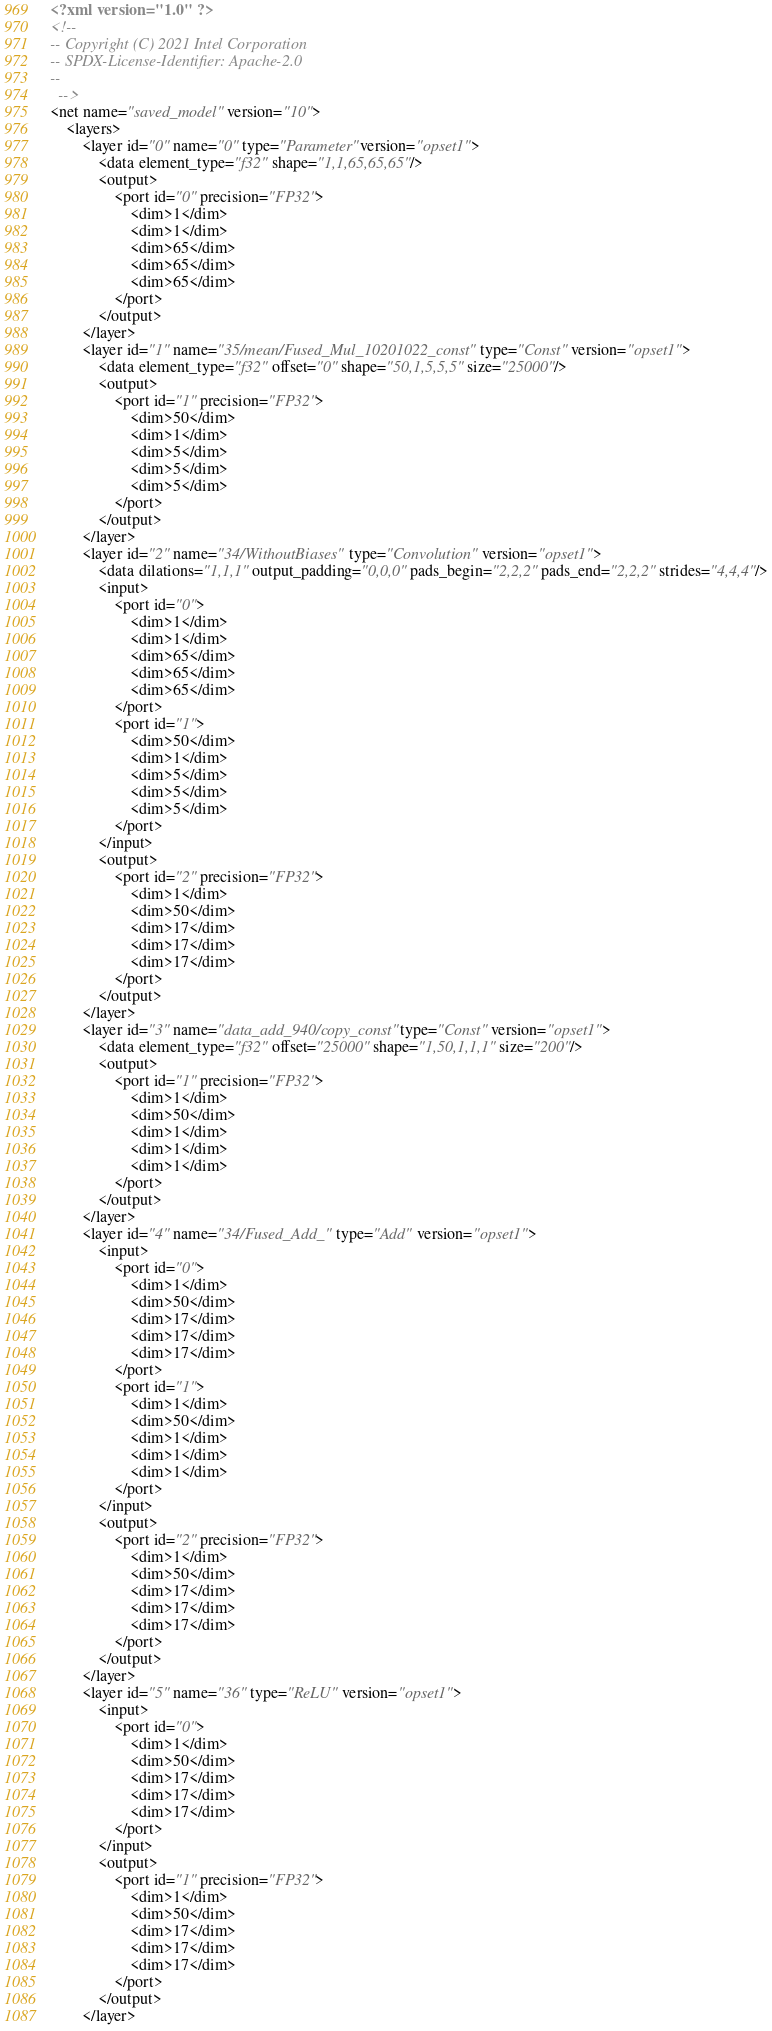<code> <loc_0><loc_0><loc_500><loc_500><_XML_><?xml version="1.0" ?>
<!--
-- Copyright (C) 2021 Intel Corporation
-- SPDX-License-Identifier: Apache-2.0
--
  -->
<net name="saved_model" version="10">
	<layers>
		<layer id="0" name="0" type="Parameter" version="opset1">
			<data element_type="f32" shape="1,1,65,65,65"/>
			<output>
				<port id="0" precision="FP32">
					<dim>1</dim>
					<dim>1</dim>
					<dim>65</dim>
					<dim>65</dim>
					<dim>65</dim>
				</port>
			</output>
		</layer>
		<layer id="1" name="35/mean/Fused_Mul_10201022_const" type="Const" version="opset1">
			<data element_type="f32" offset="0" shape="50,1,5,5,5" size="25000"/>
			<output>
				<port id="1" precision="FP32">
					<dim>50</dim>
					<dim>1</dim>
					<dim>5</dim>
					<dim>5</dim>
					<dim>5</dim>
				</port>
			</output>
		</layer>
		<layer id="2" name="34/WithoutBiases" type="Convolution" version="opset1">
			<data dilations="1,1,1" output_padding="0,0,0" pads_begin="2,2,2" pads_end="2,2,2" strides="4,4,4"/>
			<input>
				<port id="0">
					<dim>1</dim>
					<dim>1</dim>
					<dim>65</dim>
					<dim>65</dim>
					<dim>65</dim>
				</port>
				<port id="1">
					<dim>50</dim>
					<dim>1</dim>
					<dim>5</dim>
					<dim>5</dim>
					<dim>5</dim>
				</port>
			</input>
			<output>
				<port id="2" precision="FP32">
					<dim>1</dim>
					<dim>50</dim>
					<dim>17</dim>
					<dim>17</dim>
					<dim>17</dim>
				</port>
			</output>
		</layer>
		<layer id="3" name="data_add_940/copy_const" type="Const" version="opset1">
			<data element_type="f32" offset="25000" shape="1,50,1,1,1" size="200"/>
			<output>
				<port id="1" precision="FP32">
					<dim>1</dim>
					<dim>50</dim>
					<dim>1</dim>
					<dim>1</dim>
					<dim>1</dim>
				</port>
			</output>
		</layer>
		<layer id="4" name="34/Fused_Add_" type="Add" version="opset1">
			<input>
				<port id="0">
					<dim>1</dim>
					<dim>50</dim>
					<dim>17</dim>
					<dim>17</dim>
					<dim>17</dim>
				</port>
				<port id="1">
					<dim>1</dim>
					<dim>50</dim>
					<dim>1</dim>
					<dim>1</dim>
					<dim>1</dim>
				</port>
			</input>
			<output>
				<port id="2" precision="FP32">
					<dim>1</dim>
					<dim>50</dim>
					<dim>17</dim>
					<dim>17</dim>
					<dim>17</dim>
				</port>
			</output>
		</layer>
		<layer id="5" name="36" type="ReLU" version="opset1">
			<input>
				<port id="0">
					<dim>1</dim>
					<dim>50</dim>
					<dim>17</dim>
					<dim>17</dim>
					<dim>17</dim>
				</port>
			</input>
			<output>
				<port id="1" precision="FP32">
					<dim>1</dim>
					<dim>50</dim>
					<dim>17</dim>
					<dim>17</dim>
					<dim>17</dim>
				</port>
			</output>
		</layer></code> 